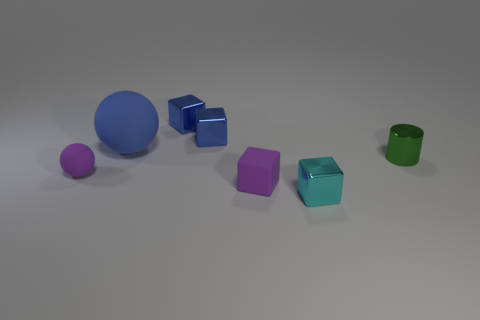Are there any other things that have the same size as the blue rubber thing?
Your answer should be very brief. No. There is a matte thing that is the same color as the tiny sphere; what size is it?
Keep it short and to the point. Small. There is a tiny matte thing that is the same color as the rubber block; what is its shape?
Give a very brief answer. Sphere. What is the size of the metal object that is on the right side of the tiny shiny thing in front of the shiny object on the right side of the cyan thing?
Your response must be concise. Small. What is the material of the green thing?
Ensure brevity in your answer.  Metal. Is the material of the purple sphere the same as the small purple object that is on the right side of the big blue matte ball?
Offer a very short reply. Yes. Is there any other thing that is the same color as the big rubber object?
Provide a short and direct response. Yes. There is a sphere that is right of the rubber ball that is in front of the blue matte thing; are there any tiny cyan shiny objects that are behind it?
Ensure brevity in your answer.  No. What color is the small metal cylinder?
Give a very brief answer. Green. Are there any small shiny objects on the right side of the green metal cylinder?
Make the answer very short. No. 